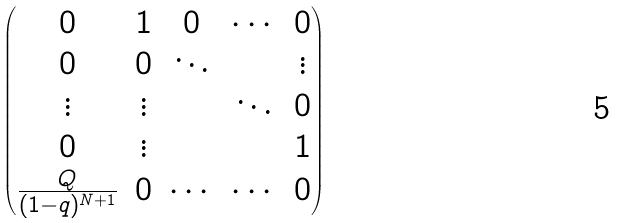Convert formula to latex. <formula><loc_0><loc_0><loc_500><loc_500>\begin{pmatrix} 0 & 1 & 0 & \cdots & 0 \\ 0 & 0 & \ddots & & \vdots \\ \vdots & \vdots & & \ddots & 0 \\ 0 & \vdots & & & 1 \\ \frac { Q } { ( 1 - q ) ^ { N + 1 } } & 0 & \cdots & \cdots & 0 \end{pmatrix}</formula> 